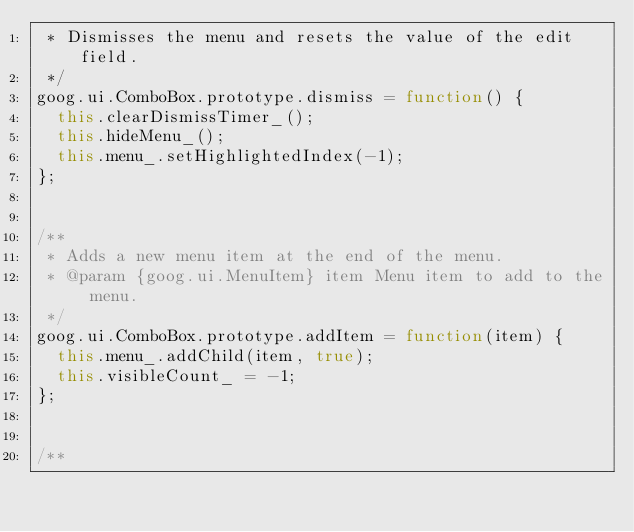Convert code to text. <code><loc_0><loc_0><loc_500><loc_500><_JavaScript_> * Dismisses the menu and resets the value of the edit field.
 */
goog.ui.ComboBox.prototype.dismiss = function() {
  this.clearDismissTimer_();
  this.hideMenu_();
  this.menu_.setHighlightedIndex(-1);
};


/**
 * Adds a new menu item at the end of the menu.
 * @param {goog.ui.MenuItem} item Menu item to add to the menu.
 */
goog.ui.ComboBox.prototype.addItem = function(item) {
  this.menu_.addChild(item, true);
  this.visibleCount_ = -1;
};


/**</code> 